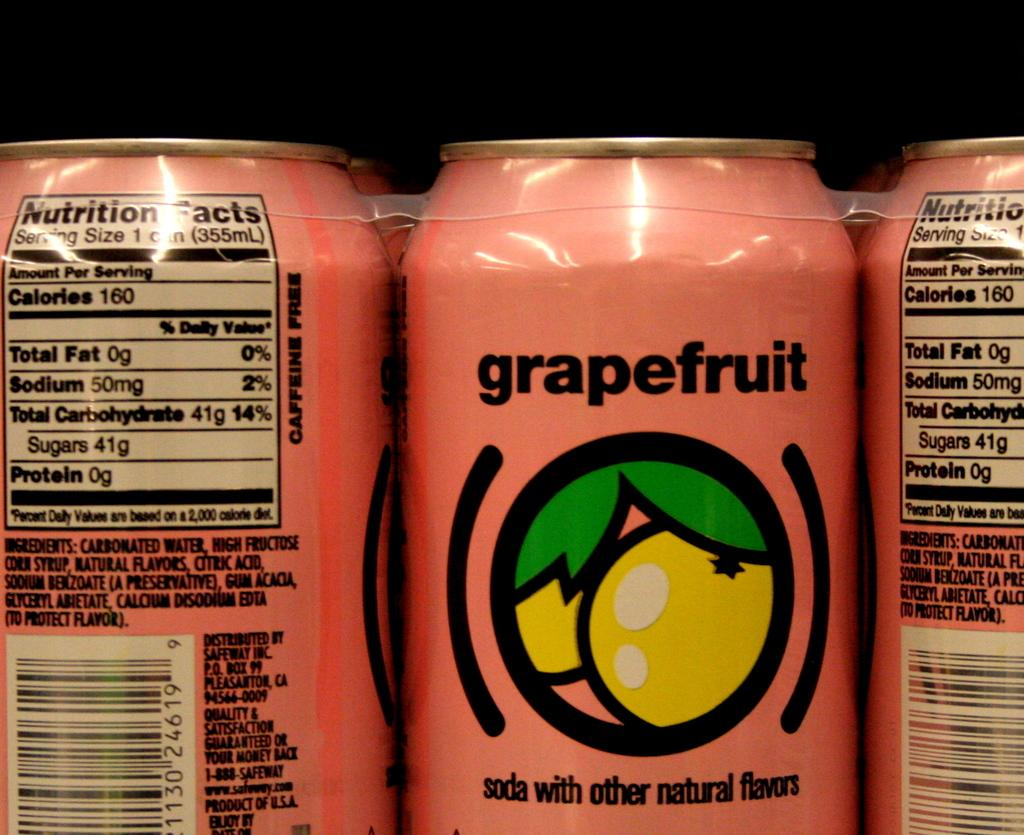<image>
Provide a brief description of the given image. A pink can with a lemon logo called grapefruit: soda with other natural flavors 